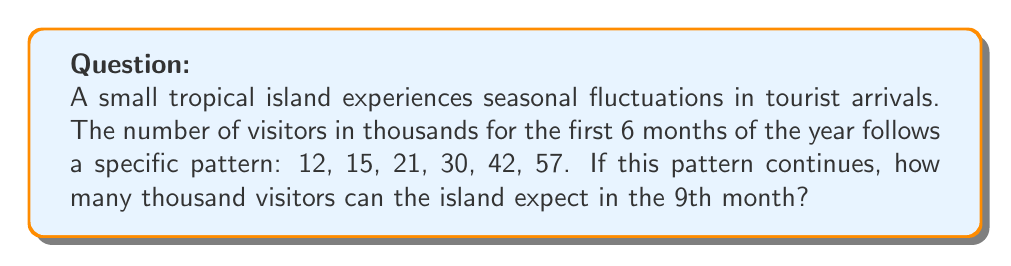Provide a solution to this math problem. To solve this problem, we need to identify the pattern in the given sequence:

12, 15, 21, 30, 42, 57

Let's calculate the differences between consecutive terms:

1. From 12 to 15: $15 - 12 = 3$
2. From 15 to 21: $21 - 15 = 6$
3. From 21 to 30: $30 - 21 = 9$
4. From 30 to 42: $42 - 30 = 12$
5. From 42 to 57: $57 - 42 = 15$

We can observe that the differences form an arithmetic sequence: 3, 6, 9, 12, 15

The pattern is that each difference increases by 3 compared to the previous one.

To find the 9th term, we need to continue this pattern for three more months:

6. 7th month: $57 + (15 + 3) = 57 + 18 = 75$
7. 8th month: $75 + (18 + 3) = 75 + 21 = 96$
8. 9th month: $96 + (21 + 3) = 96 + 24 = 120$

Therefore, the island can expect 120 thousand visitors in the 9th month.
Answer: 120 